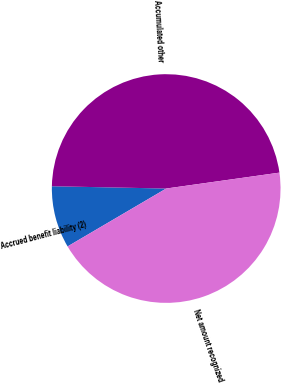Convert chart. <chart><loc_0><loc_0><loc_500><loc_500><pie_chart><fcel>Accrued benefit liability (2)<fcel>Accumulated other<fcel>Net amount recognized<nl><fcel>8.77%<fcel>47.46%<fcel>43.77%<nl></chart> 